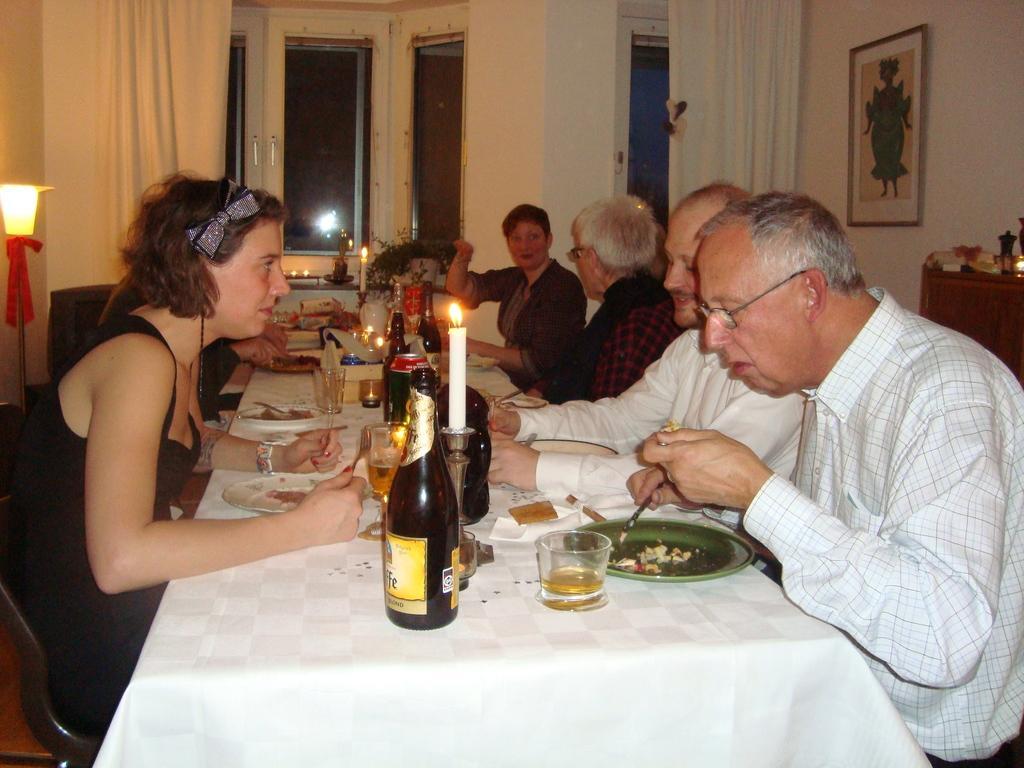Could you give a brief overview of what you see in this image? In this image I can see the group of people sitting. In front of them there is a table. On the table there is a plate, bottle,glass,spoon,candle and I can also see a window in this room. There is a wall with frame attached to it. I can also see a lamp. 